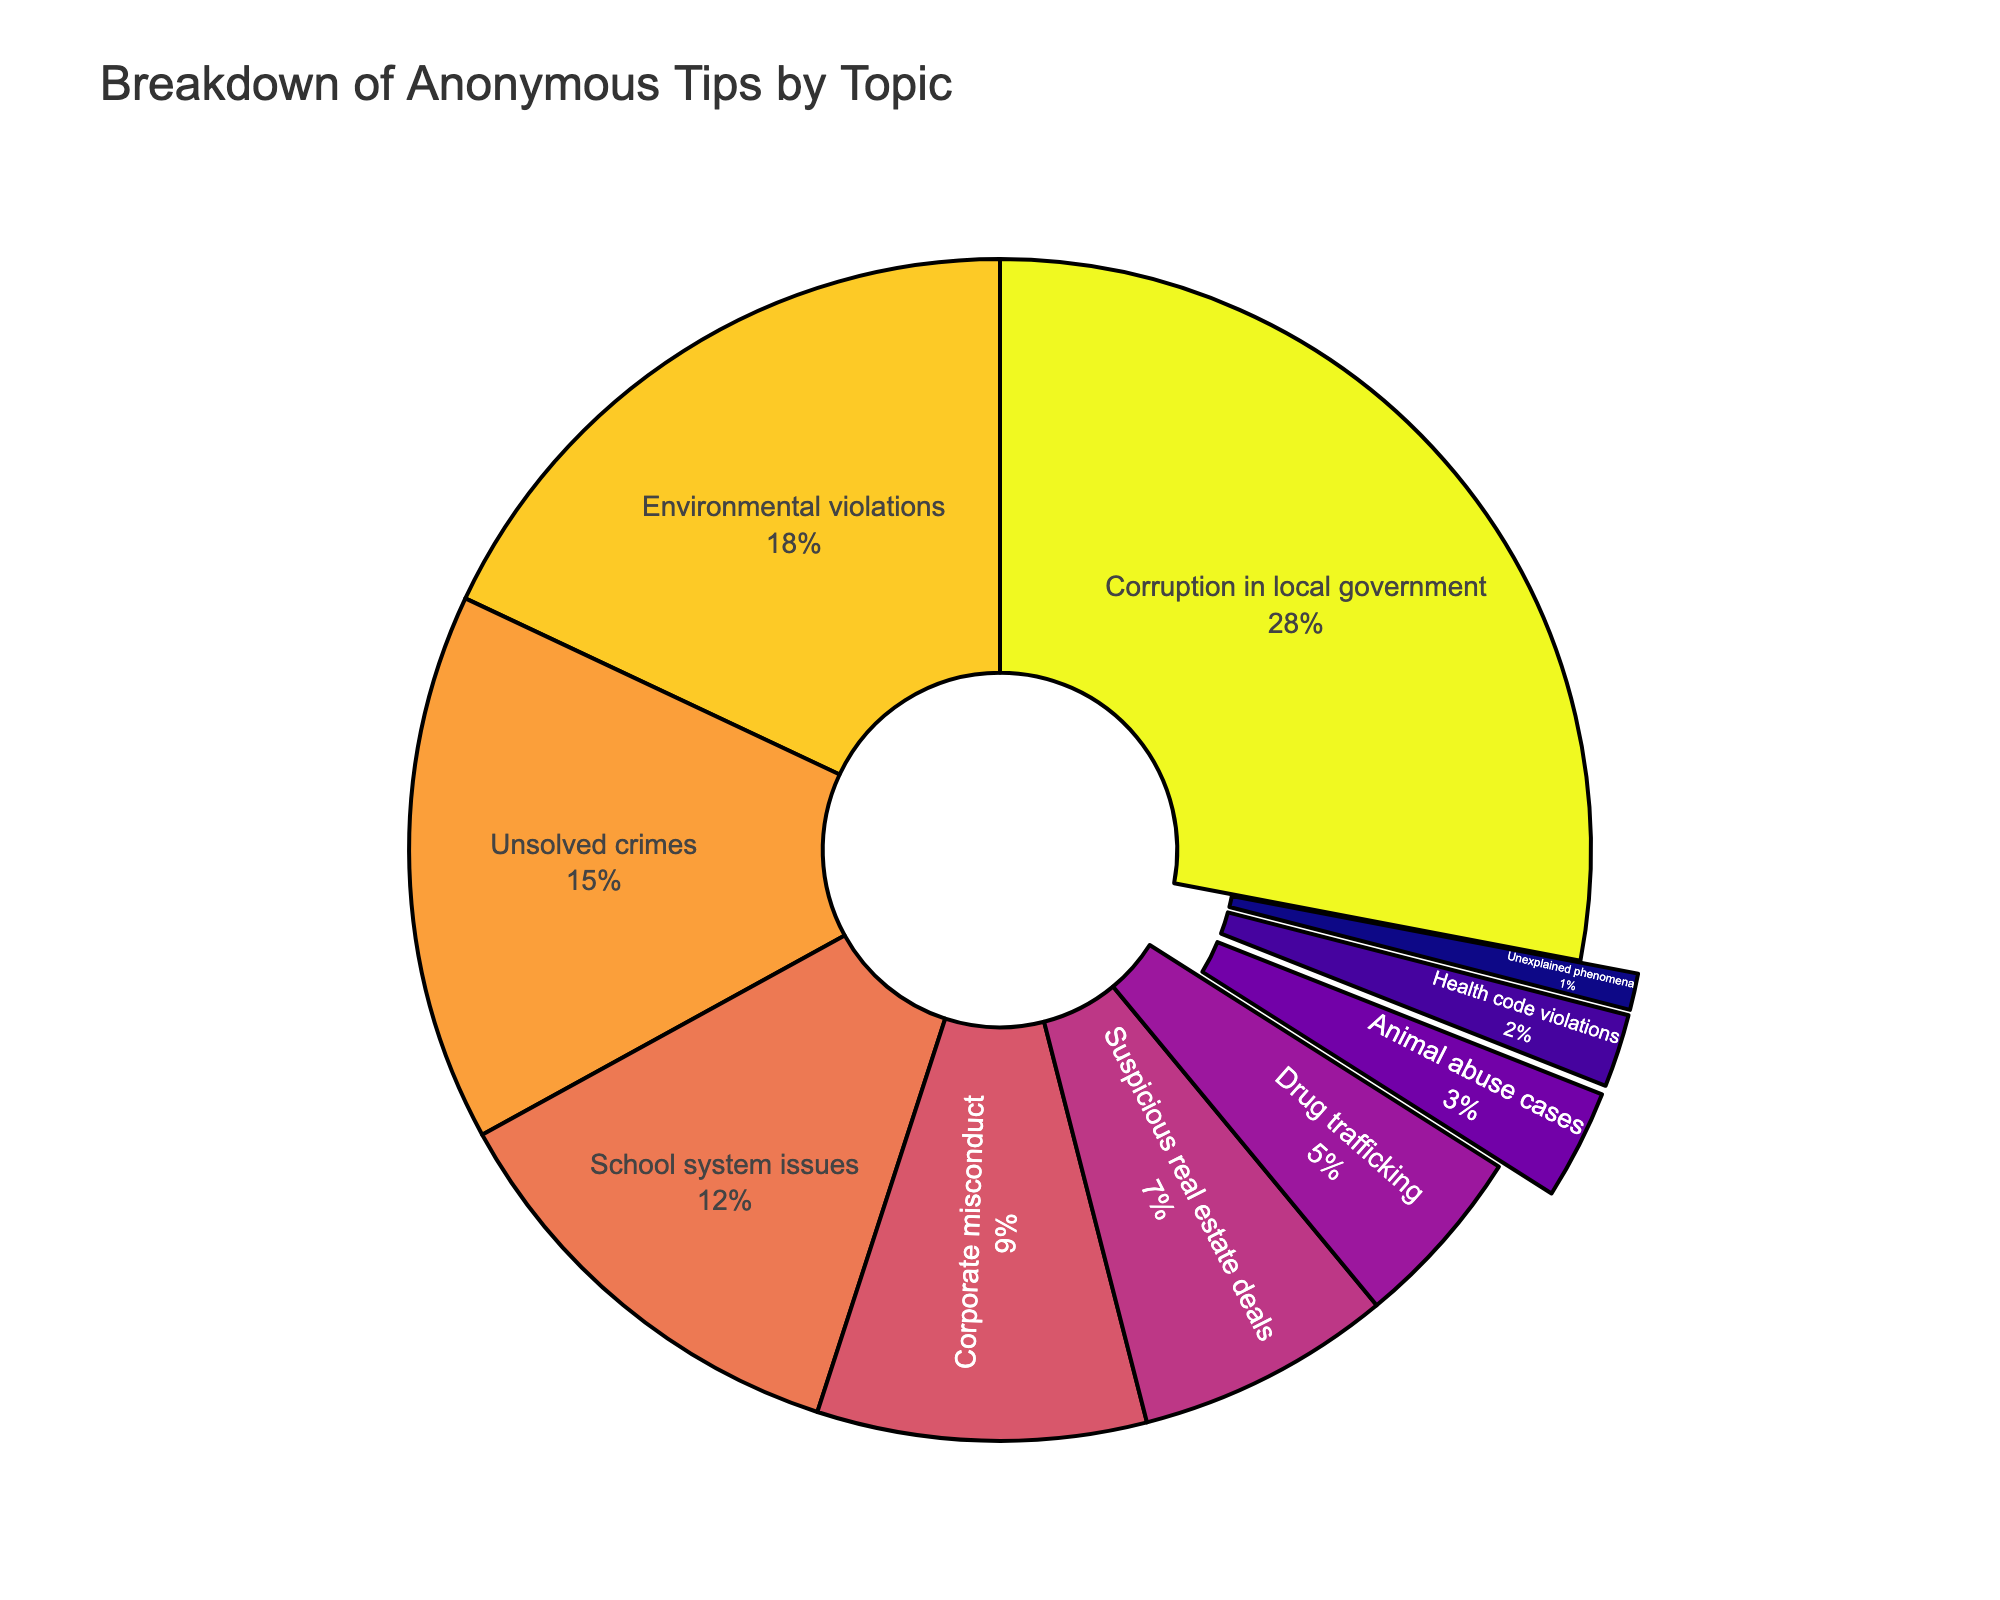Which topic received the highest percentage of anonymous tips? Identify the segment with the largest slice in the pie chart. The slice with the highest percentage should be labeled.
Answer: Corruption in local government How many topics received less than 10% of the tips each? Count the segments labeled with percentages less than 10%.
Answer: 5 What is the combined percentage of tips related to corporate misconduct and suspicious real estate deals? Add the percentages for corporate misconduct (9%) and suspicious real estate deals (7%). 9% + 7% = 16%
Answer: 16% Which topics received tips close (within 5%) to the amount received by unsolved crimes? Identify segments whose percentages fall within the 10% to 20% range since unsolved crimes have 15%. School system issues (12%) are within this range.
Answer: School system issues Are there more tips related to environmental violations or school system issues? Compare the percentages for environmental violations (18%) and school system issues (12%) to see which is larger.
Answer: Environmental violations What's the total percentage of tips related to issues within the local government system (sum of the tips for corruption in local government and school system issues)? Add the percentages for corruption in local government (28%) and school system issues (12%). 28% + 12% = 40%
Answer: 40% What is the difference in percentage between tips related to drug trafficking and animal abuse cases? Subtract the percentage for animal abuse cases (3%) from drug trafficking (5%). 5% - 3% = 2%
Answer: 2% Which topic is represented by the smallest slice of the pie chart? Identify the smallest segment in the pie chart, which should be labeled with the smallest percentage.
Answer: Unexplained phenomena 